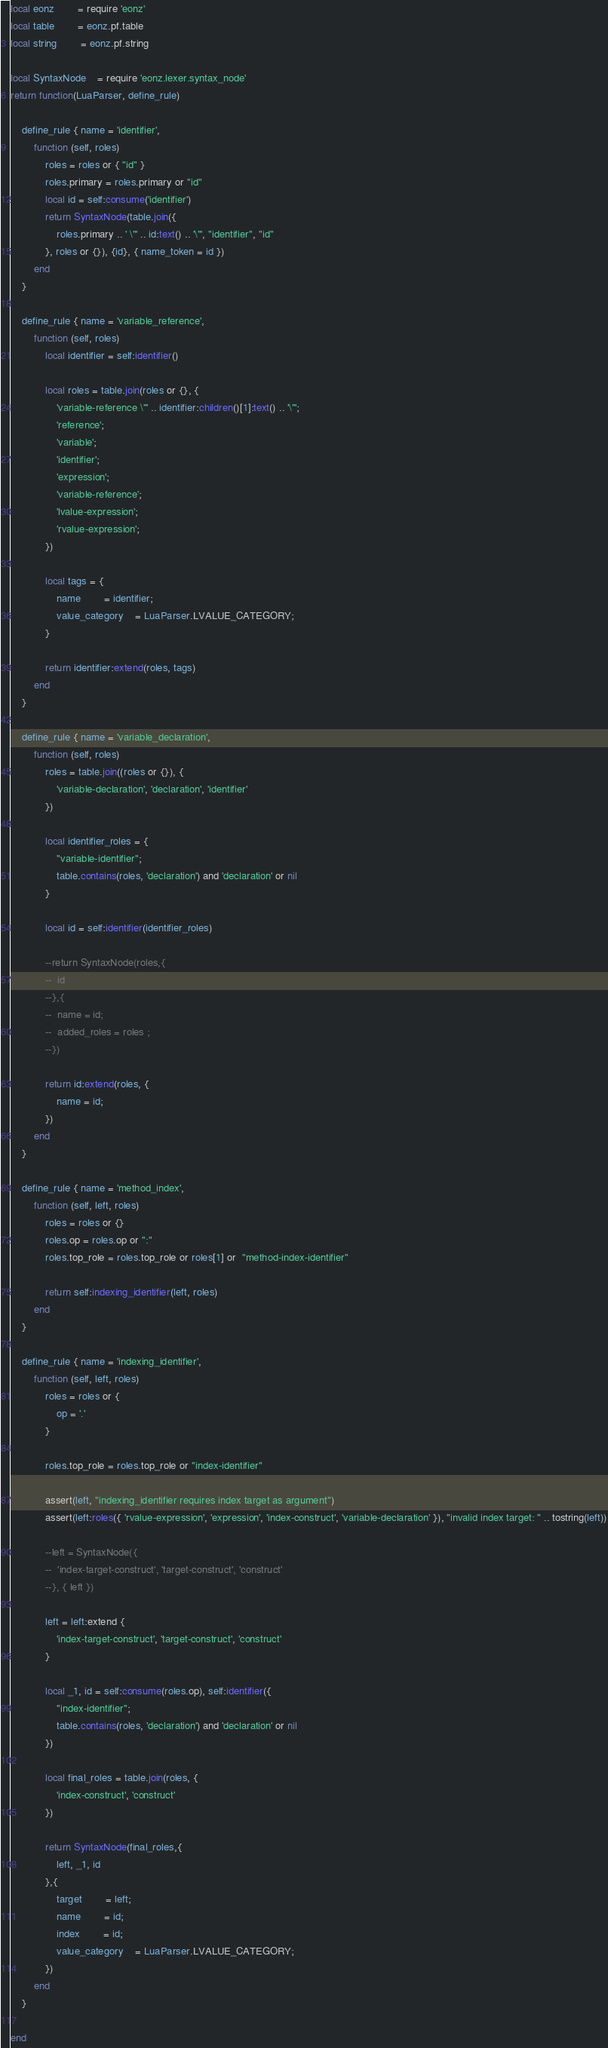Convert code to text. <code><loc_0><loc_0><loc_500><loc_500><_Lua_>local eonz 		= require 'eonz'
local table 		= eonz.pf.table
local string 		= eonz.pf.string

local SyntaxNode	= require 'eonz.lexer.syntax_node'
return function(LuaParser, define_rule)

	define_rule { name = 'identifier',
		function (self, roles)
			roles = roles or { "id" }
			roles.primary = roles.primary or "id"
			local id = self:consume('identifier')
			return SyntaxNode(table.join({
				roles.primary .. ' \"' .. id:text() .. '\"', "identifier", "id"
			}, roles or {}), {id}, { name_token = id })
		end
	}

	define_rule { name = 'variable_reference',
		function (self, roles)
			local identifier = self:identifier()

			local roles = table.join(roles or {}, {
				'variable-reference \"' .. identifier:children()[1]:text() .. '\"';
				'reference';
				'variable';
				'identifier';
				'expression';
				'variable-reference';
				'lvalue-expression';
				'rvalue-expression';
			})

			local tags = {
				name 		= identifier;
				value_category	= LuaParser.LVALUE_CATEGORY;
			}

			return identifier:extend(roles, tags)
		end
	}

	define_rule { name = 'variable_declaration',
		function (self, roles)
			roles = table.join((roles or {}), {
				'variable-declaration', 'declaration', 'identifier'
			})

			local identifier_roles = {
				"variable-identifier";
				table.contains(roles, 'declaration') and 'declaration' or nil
			}

			local id = self:identifier(identifier_roles)

			--return SyntaxNode(roles,{
			--	id
			--},{
			--	name = id;
			--	added_roles = roles ;
			--})

			return id:extend(roles, {
				name = id;
			})
		end
	}

	define_rule { name = 'method_index',
		function (self, left, roles)
			roles = roles or {}
			roles.op = roles.op or ":"
			roles.top_role = roles.top_role or roles[1] or  "method-index-identifier"

			return self:indexing_identifier(left, roles)
		end
	}

	define_rule { name = 'indexing_identifier',
		function (self, left, roles)
			roles = roles or {
				op = '.'
			}

			roles.top_role = roles.top_role or "index-identifier"

			assert(left, "indexing_identifier requires index target as argument")
			assert(left:roles({ 'rvalue-expression', 'expression', 'index-construct', 'variable-declaration' }), "invalid index target: " .. tostring(left))

			--left = SyntaxNode({
			--	'index-target-construct', 'target-construct', 'construct'
			--}, { left })

			left = left:extend {
				'index-target-construct', 'target-construct', 'construct'
			}

			local _1, id = self:consume(roles.op), self:identifier({
				"index-identifier";
				table.contains(roles, 'declaration') and 'declaration' or nil
			})

			local final_roles = table.join(roles, {
				'index-construct', 'construct'
			})

			return SyntaxNode(final_roles,{
				left, _1, id
			},{
				target		= left;
				name 		= id;
				index 		= id;
				value_category	= LuaParser.LVALUE_CATEGORY;
			})
		end
	}

end
</code> 